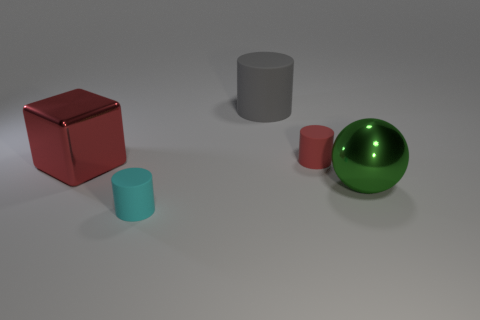Are there the same number of metallic objects that are behind the big gray cylinder and large green spheres that are in front of the red metal thing?
Give a very brief answer. No. How many other objects are there of the same color as the large shiny block?
Provide a short and direct response. 1. Are there the same number of red matte cylinders that are to the left of the large red shiny cube and gray rubber things?
Your response must be concise. No. Does the green metallic object have the same size as the cyan object?
Offer a very short reply. No. There is a thing that is in front of the big red block and behind the cyan thing; what material is it made of?
Offer a very short reply. Metal. What number of big brown matte objects have the same shape as the tiny red thing?
Offer a very short reply. 0. There is a tiny thing in front of the big metal sphere; what is it made of?
Provide a succinct answer. Rubber. Are there fewer green shiny spheres in front of the large gray cylinder than small yellow metallic things?
Keep it short and to the point. No. Is the big gray object the same shape as the small red thing?
Make the answer very short. Yes. Are there any other things that have the same shape as the gray matte object?
Provide a short and direct response. Yes. 